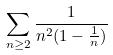Convert formula to latex. <formula><loc_0><loc_0><loc_500><loc_500>\sum _ { n \geq 2 } \frac { 1 } { n ^ { 2 } ( 1 - \frac { 1 } { n } ) }</formula> 